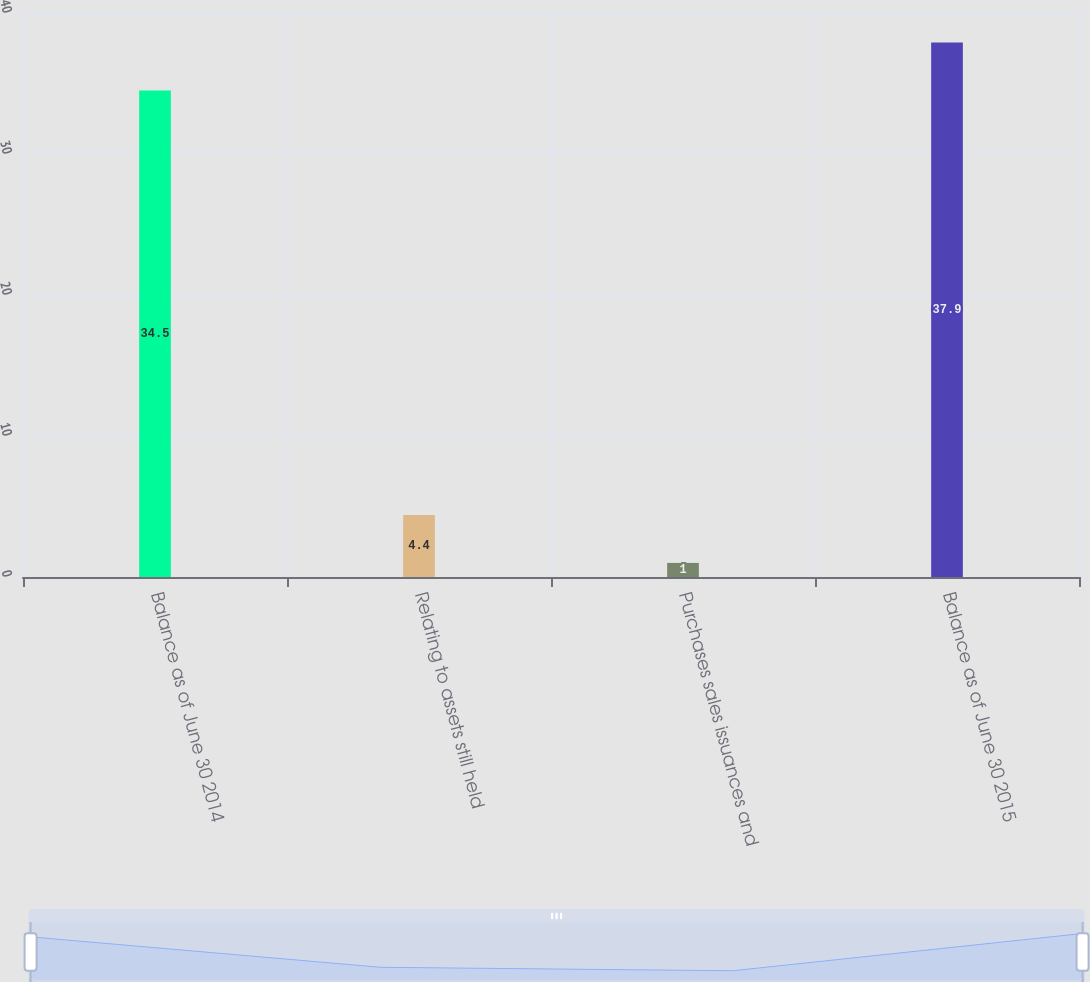<chart> <loc_0><loc_0><loc_500><loc_500><bar_chart><fcel>Balance as of June 30 2014<fcel>Relating to assets still held<fcel>Purchases sales issuances and<fcel>Balance as of June 30 2015<nl><fcel>34.5<fcel>4.4<fcel>1<fcel>37.9<nl></chart> 